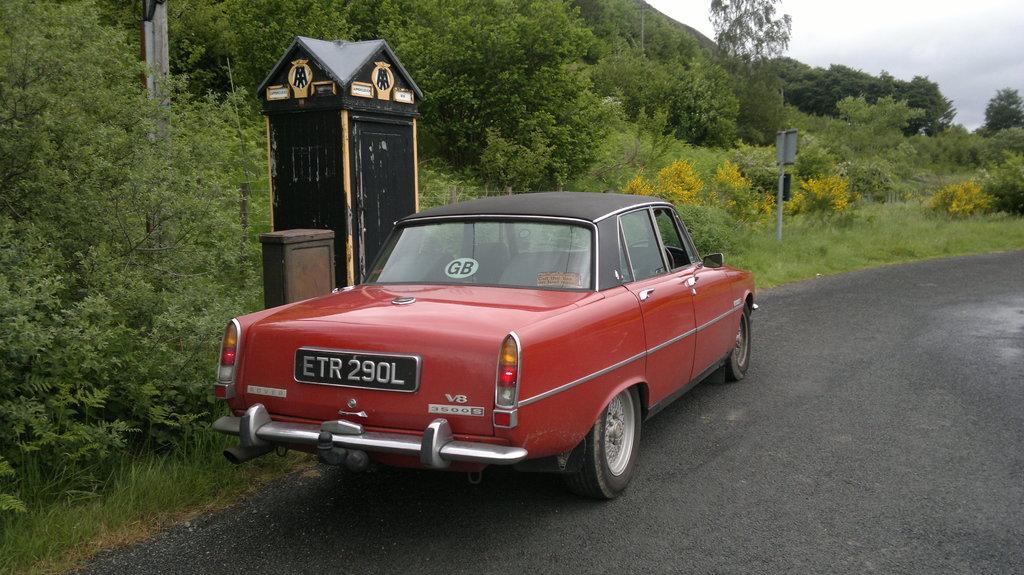Describe this image in one or two sentences. In this image I can see the road, a car which is red and black in color on the road, a small shed which is black and yellow in color, few trees which are green and yellow in color and few poles. In the background I can see the sky. 